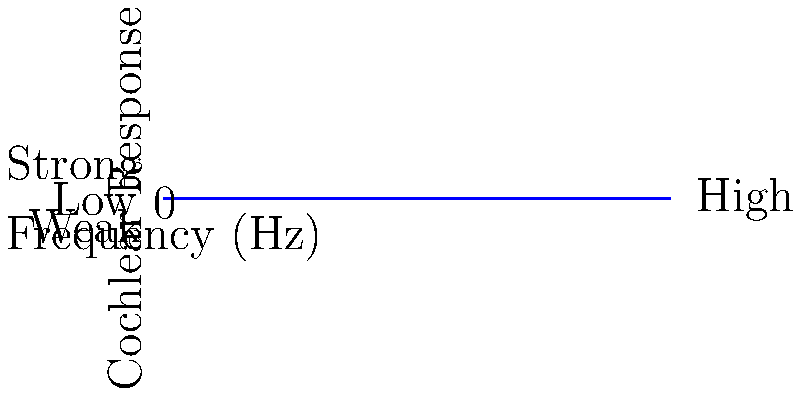Based on the graph showing cochlear response to different sound frequencies, which frequency range appears to elicit the strongest response from the cochlea, and how might this impact a musician with hearing impairment? 1. Analyze the graph:
   - The x-axis represents frequency in Hz
   - The y-axis represents the strength of cochlear response

2. Identify the peak of the curve:
   - The highest point on the curve indicates the strongest cochlear response
   - This peak occurs around 1000 Hz

3. Interpret the frequency range:
   - The curve shows a bell-shaped response
   - Strong responses occur roughly between 500 Hz and 1500 Hz
   - This range corresponds to mid-frequency sounds

4. Consider the implications for a musician with hearing impairment:
   - Mid-frequency sounds (around 1000 Hz) would be most easily perceived
   - Lower and higher frequencies would elicit weaker responses
   - This could affect the ability to hear certain instruments or notes clearly

5. Impact on musical performance:
   - Difficulty in perceiving low bass notes or high treble notes
   - Potential challenges in tuning instruments or hearing harmonics
   - May need to rely more on visual cues or vibrations for certain frequency ranges

6. Adaptation strategies:
   - Focus on instruments or musical styles that emphasize mid-range frequencies
   - Use assistive listening devices that can amplify weaker frequency responses
   - Develop techniques to compensate for reduced perception of certain frequencies
Answer: Mid-range frequencies around 1000 Hz; impacts perception of low and high notes, requiring adaptive strategies. 